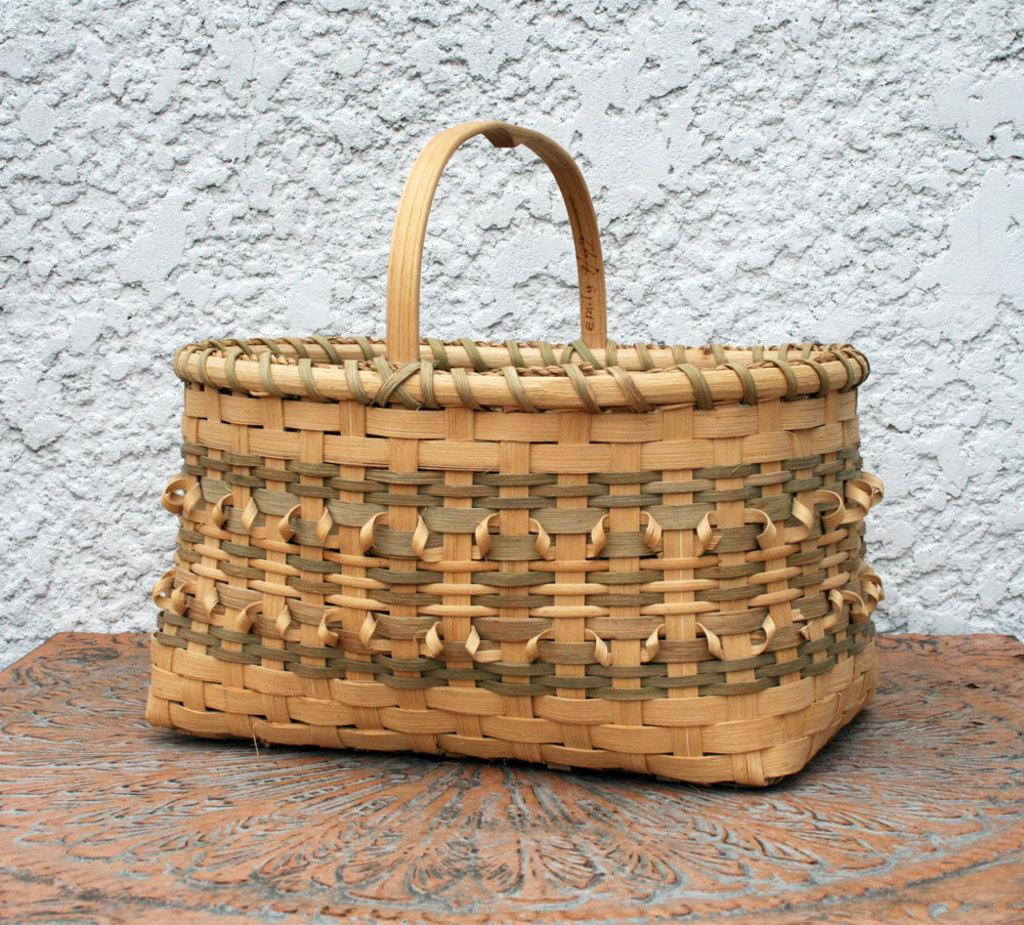What object can be seen in the image? There is a basket in the image. How many babies are crawling out of the basket in the image? There are no babies present in the image; it only features a basket. What type of snake can be seen coiled around the basket in the image? There are no snakes present in the image; it only features a basket. 